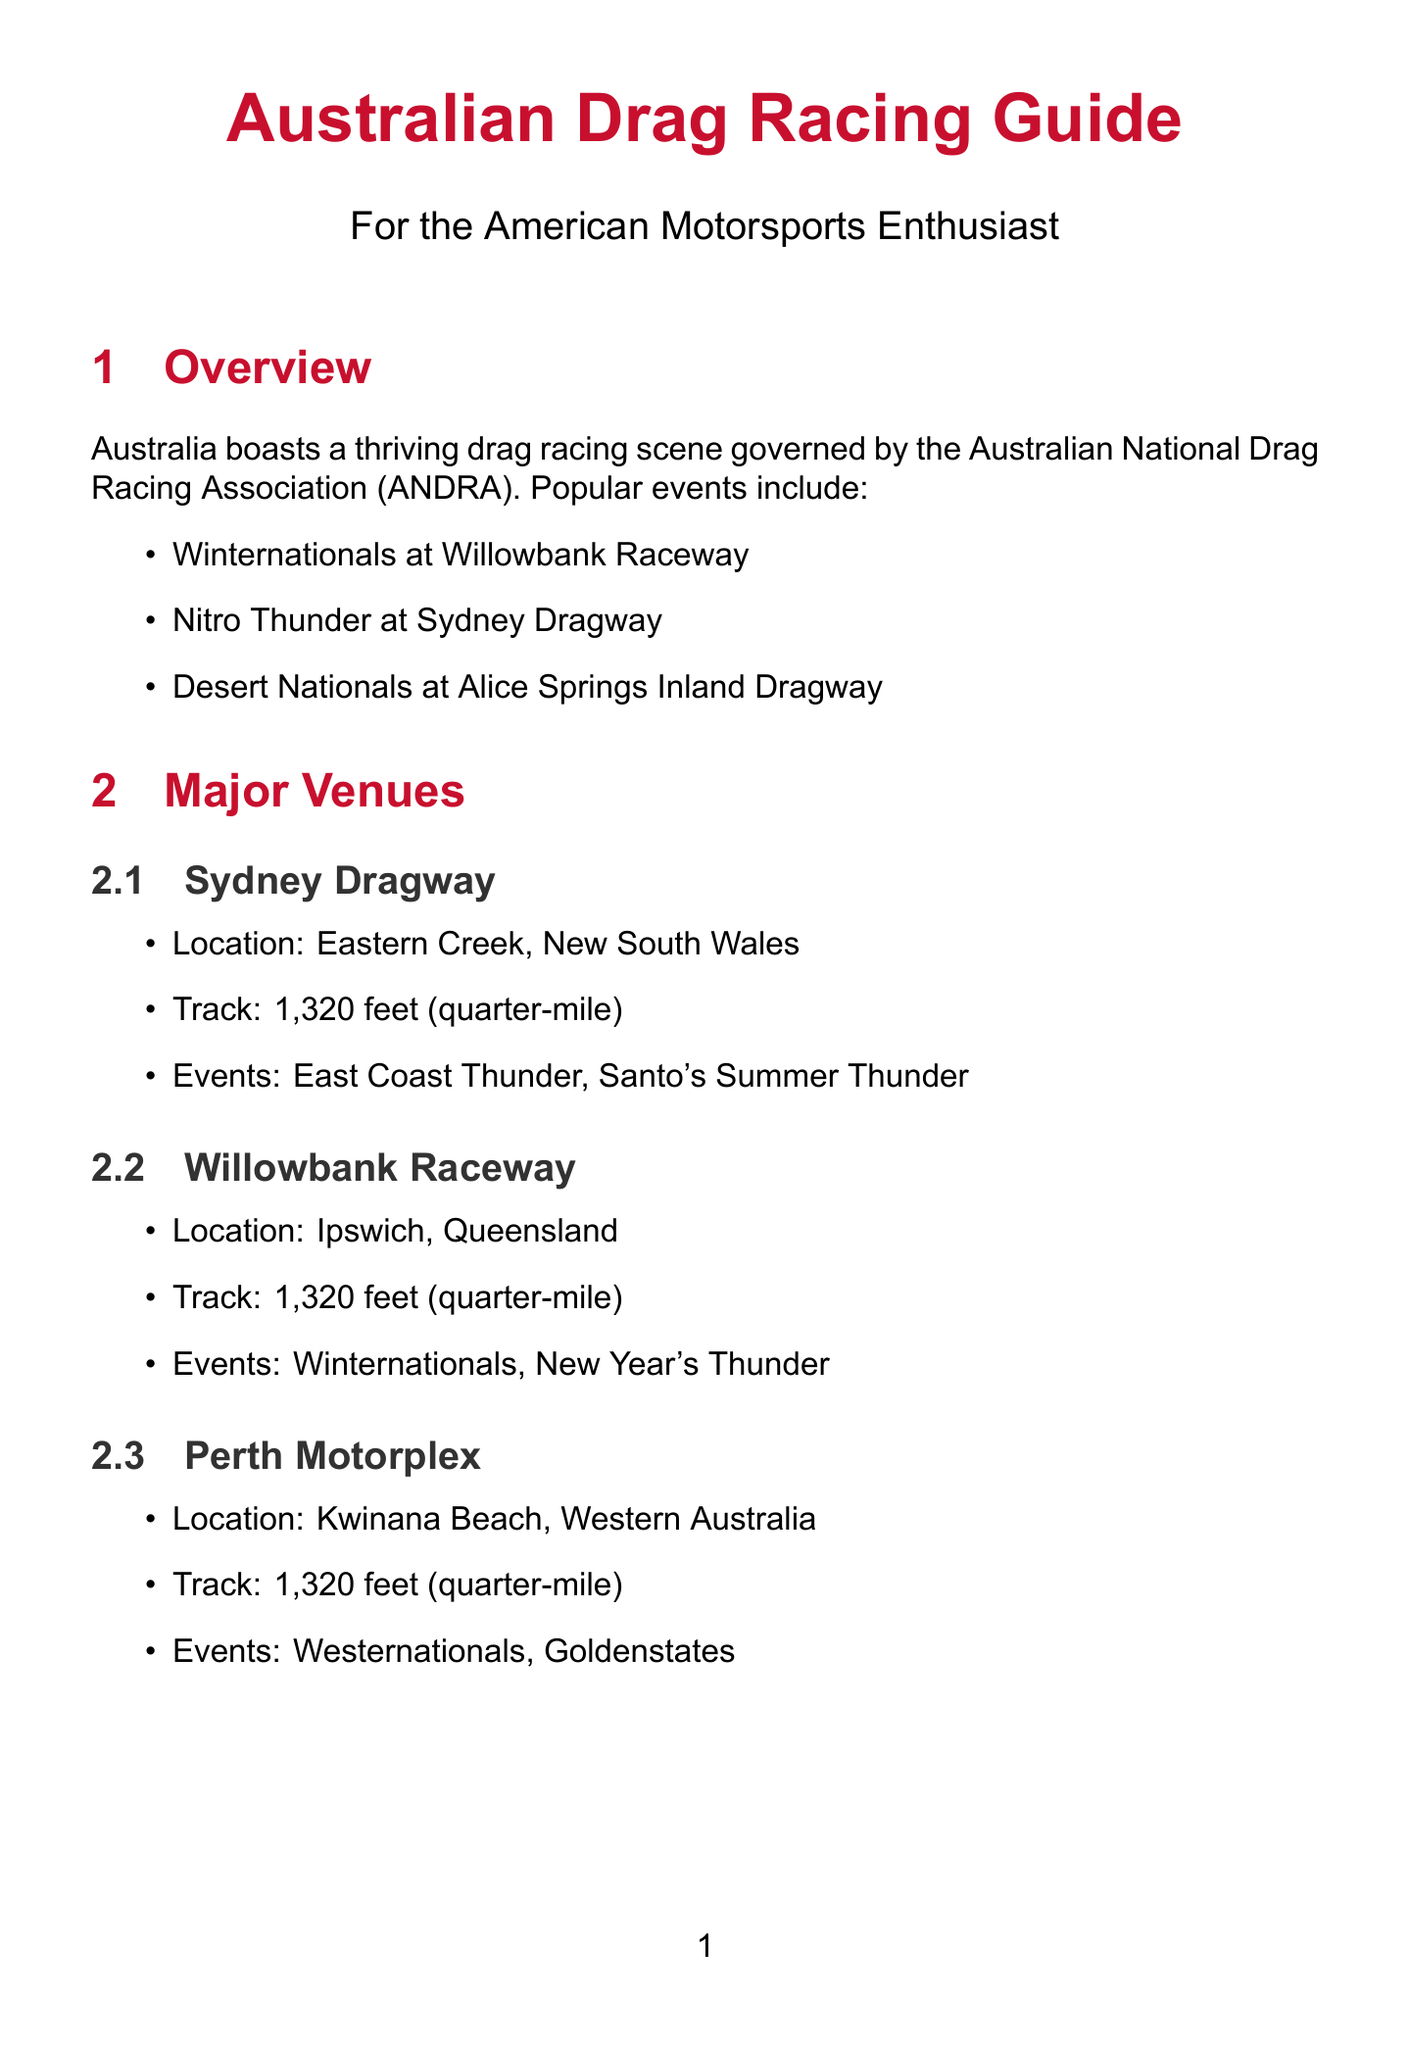What is the governing body for Australian drag racing? The governing body for Australian drag racing is mentioned in the overview section of the document.
Answer: Australian National Drag Racing Association (ANDRA) What is the track length at Sydney Dragway? The track length is specified in the details for Sydney Dragway under major venues.
Answer: 1,320 feet (quarter-mile) When do the Winternationals take place? The date for the Winternationals is provided in the major events section of the race schedules.
Answer: June 8-11, 2023 What type of license is required for racing? The type of license is mentioned in the local regulations section regarding licensing.
Answer: ANDRA competition license What is a unique class found in Australian drag racing? This is outlined in the unique Australian aspects section, referring to specific classes.
Answer: Top Doorslammer What is the general admission ticket price range? The ticket price range is found in the spectator information section of the document.
Answer: $25-$50 AUD What is the best time to visit for drag racing events? This information is provided in the travel tips section, outlining the racing season.
Answer: Year-round Which venue hosts the Nitro Thunder event? The specific venue hosting the Nitro Thunder is available in the major events list under race schedules.
Answer: Sydney Dragway How often do most venues host test and tune sessions? This detail can be found in the race schedules section, which discusses regular events.
Answer: Weekly or bi-weekly 